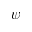<formula> <loc_0><loc_0><loc_500><loc_500>\psi</formula> 